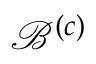Convert formula to latex. <formula><loc_0><loc_0><loc_500><loc_500>\mathcal { B } ^ { \left ( c \right ) }</formula> 